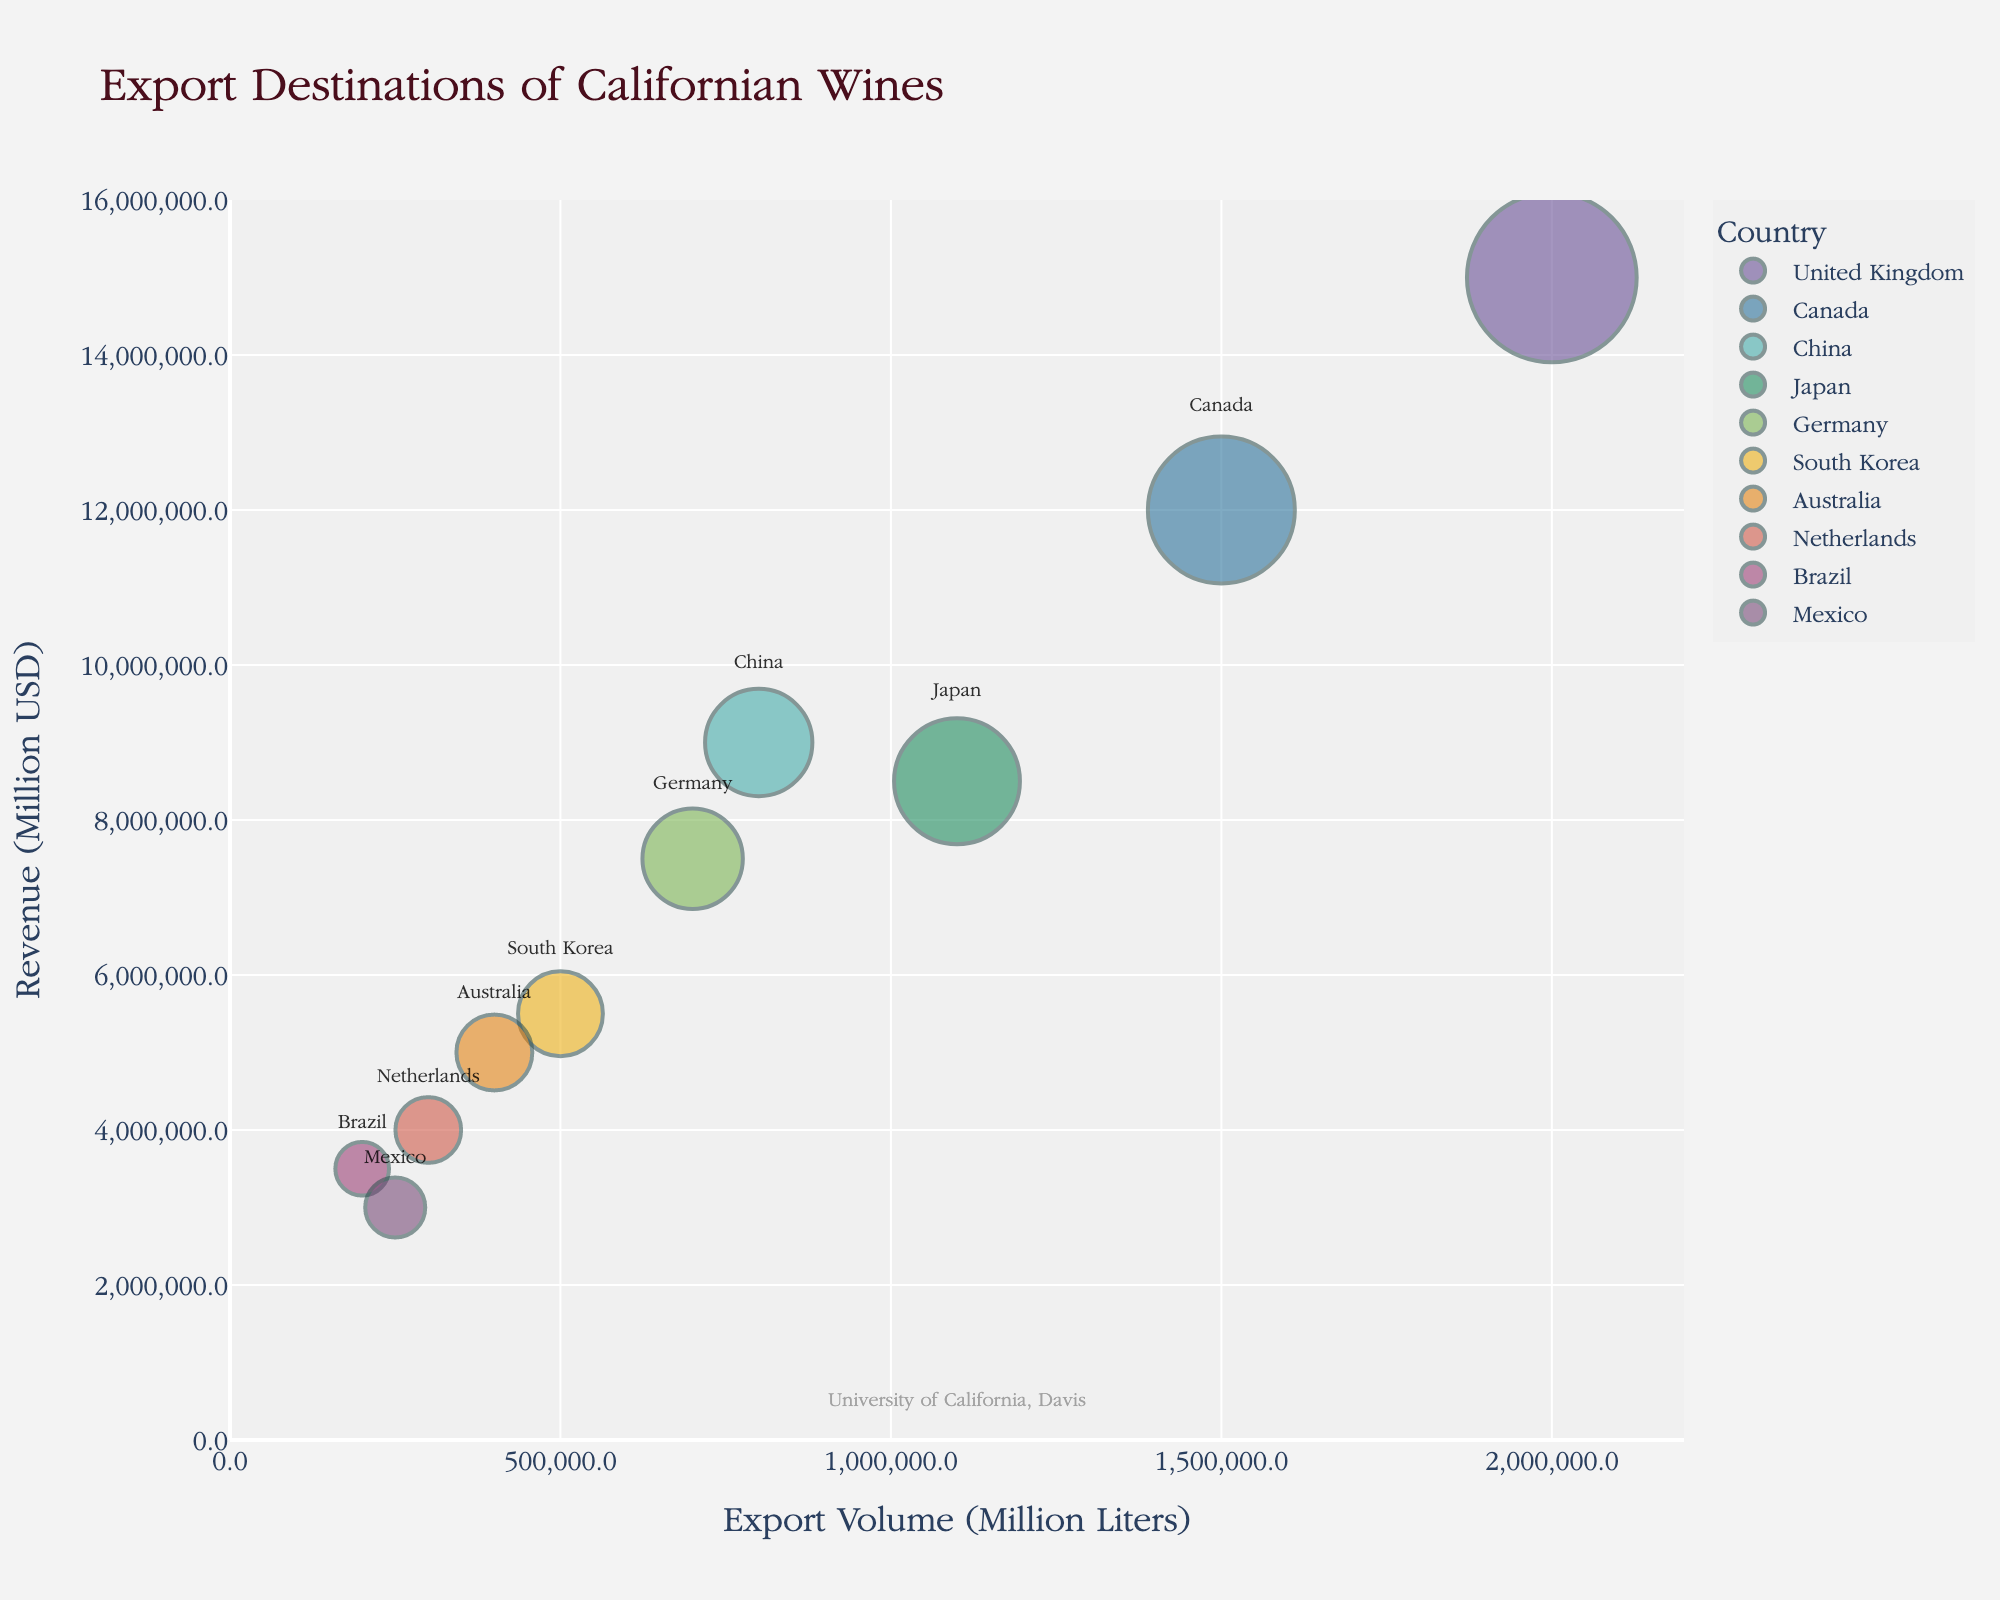What is the title of the figure? The title is displayed at the top of the chart and provides an overview of what the figure represents.
Answer: Export Destinations of Californian Wines How many countries are listed in the chart? Count the number of different bubbles, each bubble represents a country.
Answer: 10 Which country has the highest export volume? Find the largest bubble along the x-axis, representing export volume.
Answer: United Kingdom Which country generates the highest revenue? Identify the bubble that reaches the highest point along the y-axis, representing revenue.
Answer: United Kingdom What is the export volume for Canada? Locate the bubble labeled "Canada" and read the value on the x-axis.
Answer: 1,500,000 Liters What is the total export volume for Brazil and Mexico? Add the export volumes for Brazil (200,000 Liters) and Mexico (250,000 Liters).
Answer: 450,000 Liters How does the revenue for Japan compare to that of Germany? Identify the bubbles for Japan and Germany, then compare their positions on the y-axis.
Answer: Japan has higher revenue than Germany Which countries have an export volume greater than 1 million liters but less than 2 million liters? Identify bubbles within the x-axis range of 1,000,000 to 2,000,000 liters and read their labels.
Answer: Canada, Japan What is the average revenue for the four countries with the lowest export volumes? Identify the four smallest bubbles: Netherlands, Brazil, Mexico, and Australia. Sum their revenues (4,000,000 + 3,500,000 + 3,000,000 + 5,000,000 = 15,500,000 USD) and divide by 4.
Answer: 3,875,000 USD What color is the bubble representing South Korea? Examine the bubble color schemes and identify the color associated with "South Korea".
Answer: Color depends on the palette used, typically it's a distinct color visually set apart from others 